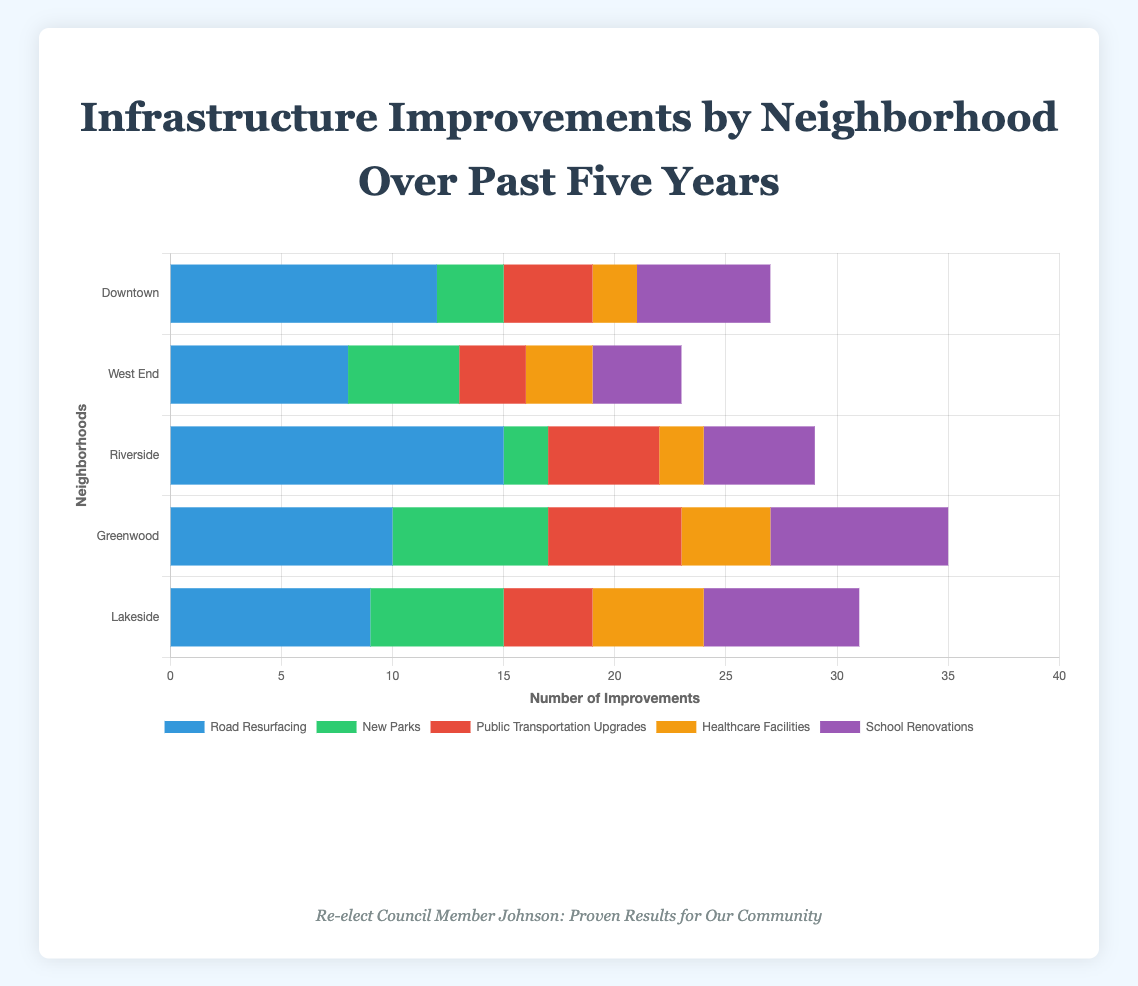Which neighborhood had the highest number of road resurfacing projects? By examining the 'Road Resurfacing' bars, the one with the greatest length represents the highest number. Here, Riverside has the longest bar with 15 projects.
Answer: Riverside How many fewer new parks were created in Downtown compared to Greenwood? Downtown has 3 new parks and Greenwood has 7. The difference is 7 - 3 = 4 parks.
Answer: 4 What is the total number of school renovations across all neighborhoods? Summing the values for 'School Renovations': 6 (Downtown) + 4 (West End) + 5 (Riverside) + 8 (Greenwood) + 7 (Lakeside) equals 30.
Answer: 30 Compare the number of healthcare facilities built in West End and Lakeside. Which neighborhood has more? West End built 3 healthcare facilities while Lakeside built 5. Therefore, Lakeside has more.
Answer: Lakeside Which type of infrastructure improvement was most frequent in Lakeside? Comparing the bar lengths for Lakeside, 'School Renovations' has the longest bar with 7 renovations.
Answer: School Renovations What's the average number of public transportation upgrades per neighborhood? Summing the values for 'Public Transportation Upgrades': 4 (Downtown) + 3 (West End) + 5 (Riverside) + 6 (Greenwood) + 4 (Lakeside) equals 22 upgrades. Dividing by 5 neighborhoods, the average is 22/5 = 4.4.
Answer: 4.4 Is the number of road resurfacing projects in Greenwood greater or fewer than the number of new parks in West End? Greenwood has 10 road resurfacing projects while West End has 5 new parks. Therefore, Greenwood has more.
Answer: Greater What is the difference between the highest and lowest number of infrastructure improvements in Downtown? 'Road Resurfacing' has the highest value of 12 and 'Healthcare Facilities' has the lowest value of 2. The difference is 12 - 2 = 10.
Answer: 10 Which neighborhood had the least number of infrastructure improvements overall, and calculate the total for that neighborhood? Summing up the improvements for each neighborhood: Downtown (27), West End (23), Riverside (29), Greenwood (35), Lakeside (31). West End has the least.
Answer: West End, 23 